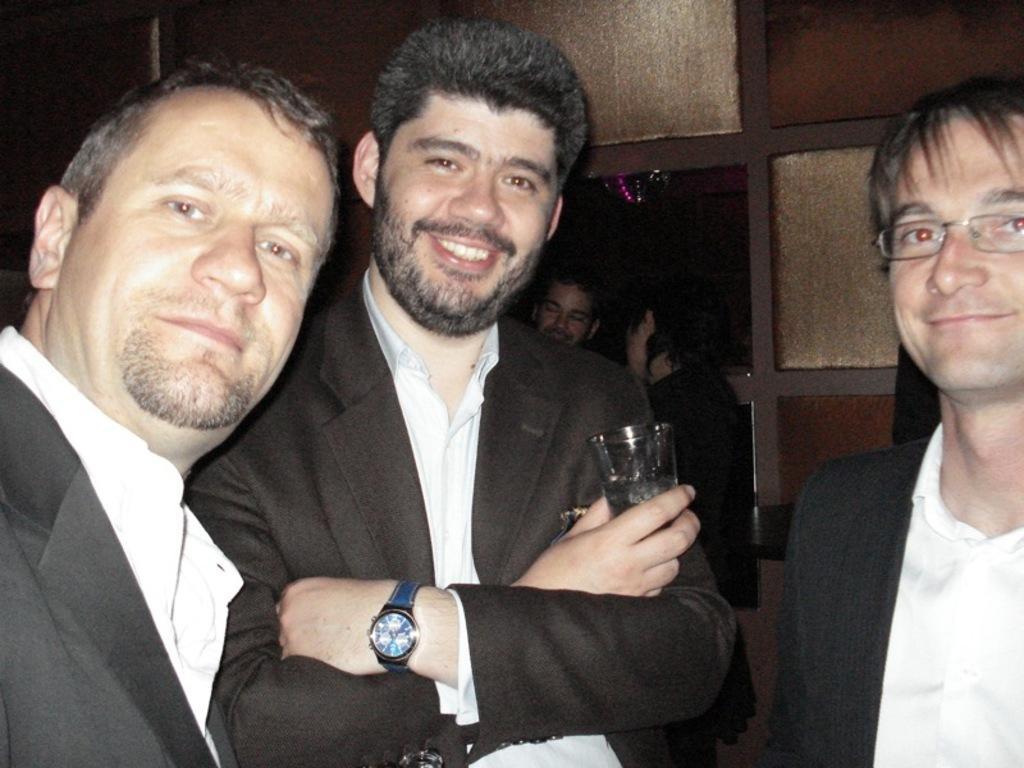In one or two sentences, can you explain what this image depicts? In this image we can see group of persons standing on the floor. One person is wearing coat and holding a glass in his hand and one person is wearing spectacles. 